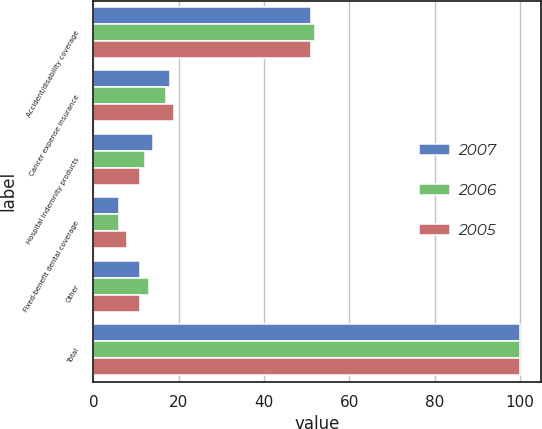Convert chart. <chart><loc_0><loc_0><loc_500><loc_500><stacked_bar_chart><ecel><fcel>Accident/disability coverage<fcel>Cancer expense insurance<fcel>Hospital indemnity products<fcel>Fixed-benefit dental coverage<fcel>Other<fcel>Total<nl><fcel>2007<fcel>51<fcel>18<fcel>14<fcel>6<fcel>11<fcel>100<nl><fcel>2006<fcel>52<fcel>17<fcel>12<fcel>6<fcel>13<fcel>100<nl><fcel>2005<fcel>51<fcel>19<fcel>11<fcel>8<fcel>11<fcel>100<nl></chart> 